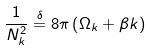<formula> <loc_0><loc_0><loc_500><loc_500>\frac { 1 } { N _ { k } ^ { 2 } } \stackrel { \delta } { = } 8 \pi \left ( \Omega _ { k } + \beta k \right )</formula> 